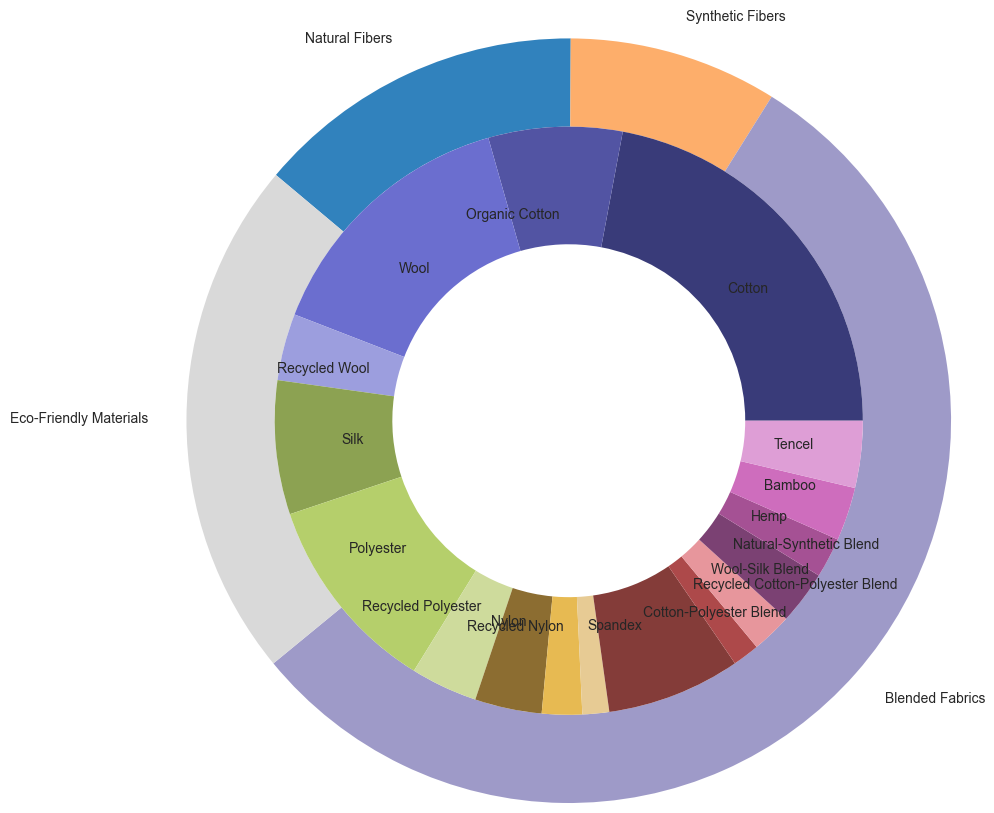What is the total usage percentage of natural fibers? To find the total usage percentage of natural fibers, sum the usage percentages of all natural fiber sub-types: Cotton (30%), Organic Cotton (10%), Wool (20%), Recycled Wool (5%), and Silk (10%). Adding these gives us 30 + 10 + 20 + 5 + 10 = 75%.
Answer: 75% Which sub-type under synthetic fibers has the highest usage percentage, and what is it? To determine the synthetic fiber sub-type with the highest usage percentage, we look at the individual usage percentages: Polyester (15%), Recycled Polyester (5%), Nylon (5%), Recycled Nylon (3%), and Spandex (2%). Polyester has the highest usage at 15%.
Answer: Polyester, 15% How does the usage of organic cotton compare to recycled wool? To compare the usage of organic cotton and recycled wool, we check their usage percentages: Organic Cotton (10%) and Recycled Wool (5%). Organic Cotton usage (10%) is higher than Recycled Wool usage (5%).
Answer: Organic Cotton is higher What is the overall usage percentage for eco-friendly materials? To find the usage percentage for eco-friendly materials, sum the percentages of Hemp (3%), Bamboo (4%), and Tencel (5%). Adding these gives us 3 + 4 + 5 = 12%.
Answer: 12% Which fabric type has the least total usage percentage? To determine the fabric type with the least total usage, sum the usage percentages for each main category: Natural Fibers (75%), Synthetic Fibers (30%), Blended Fabrics (19%), and Eco-Friendly Materials (12%). The category with the least usage is Eco-Friendly Materials with 12%.
Answer: Eco-Friendly Materials Which blended fabric sub-type has the same usage percentage as Tencel, and what is it? To find the blended fabric sub-type with the same usage as Tencel (5%), compare all blended fabric sub-types: Cotton-Polyester Blend (10%), Recycled Cotton-Polyester Blend (2%), Wool-Silk Blend (3%), and Natural-Synthetic Blend (4%). None of these sub-types have the same percentage as Tencel (5%).
Answer: None What is the combined usage percentage of all recycled materials? To find the combined usage percentage of all recycled materials, sum the percentages of Recycled Wool (5%), Recycled Polyester (5%), Recycled Nylon (3%), and Recycled Cotton-Polyester Blend (2%). Adding these gives us 5 + 5 + 3 + 2 = 15%.
Answer: 15% Which fabric type is represented by the teal color in the outer circle? By visual identification, the outer circle's section that is teal represents the Synthetic Fibers category.
Answer: Synthetic Fibers What is the difference in usage percentage between polyester and nylon? To find the difference between Polyester (15%) and Nylon (5%), subtract the smaller percentage from the larger: 15 - 5 = 10%.
Answer: 10% What percentage of natural fibers is sustainable (organic or recycled)? To find the sustainable percentage of natural fibers, sum the percentages of Organic Cotton (10%) and Recycled Wool (5%). Adding these gives us 10 + 5 = 15%.
Answer: 15% 